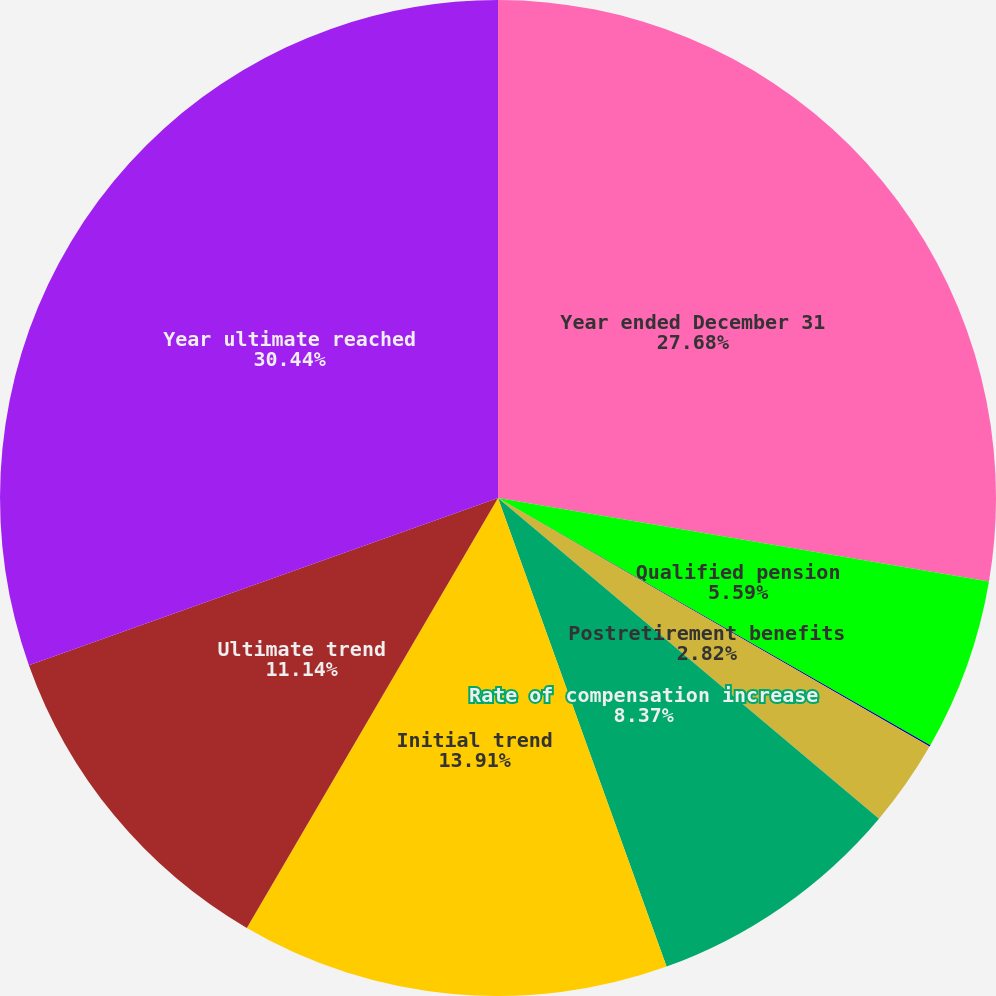Convert chart. <chart><loc_0><loc_0><loc_500><loc_500><pie_chart><fcel>Year ended December 31<fcel>Qualified pension<fcel>Nonqualified pension<fcel>Postretirement benefits<fcel>Rate of compensation increase<fcel>Initial trend<fcel>Ultimate trend<fcel>Year ultimate reached<nl><fcel>27.68%<fcel>5.59%<fcel>0.05%<fcel>2.82%<fcel>8.37%<fcel>13.91%<fcel>11.14%<fcel>30.45%<nl></chart> 